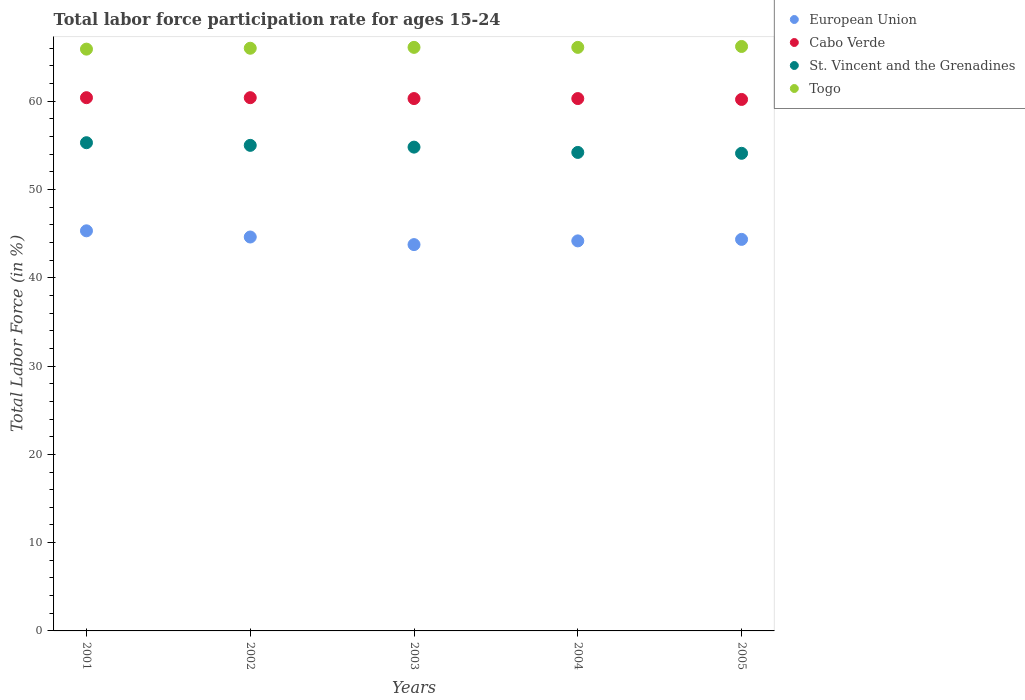Is the number of dotlines equal to the number of legend labels?
Offer a very short reply. Yes. What is the labor force participation rate in Cabo Verde in 2002?
Your answer should be very brief. 60.4. Across all years, what is the maximum labor force participation rate in St. Vincent and the Grenadines?
Make the answer very short. 55.3. Across all years, what is the minimum labor force participation rate in European Union?
Offer a very short reply. 43.76. In which year was the labor force participation rate in European Union maximum?
Provide a short and direct response. 2001. In which year was the labor force participation rate in St. Vincent and the Grenadines minimum?
Make the answer very short. 2005. What is the total labor force participation rate in European Union in the graph?
Offer a terse response. 222.23. What is the difference between the labor force participation rate in European Union in 2004 and that in 2005?
Provide a succinct answer. -0.17. What is the difference between the labor force participation rate in European Union in 2005 and the labor force participation rate in St. Vincent and the Grenadines in 2001?
Your answer should be compact. -10.95. What is the average labor force participation rate in Togo per year?
Provide a short and direct response. 66.06. In the year 2004, what is the difference between the labor force participation rate in Cabo Verde and labor force participation rate in St. Vincent and the Grenadines?
Make the answer very short. 6.1. In how many years, is the labor force participation rate in European Union greater than 54 %?
Keep it short and to the point. 0. What is the ratio of the labor force participation rate in European Union in 2004 to that in 2005?
Offer a terse response. 1. Is the labor force participation rate in Cabo Verde in 2002 less than that in 2005?
Offer a very short reply. No. What is the difference between the highest and the lowest labor force participation rate in Togo?
Your answer should be compact. 0.3. In how many years, is the labor force participation rate in St. Vincent and the Grenadines greater than the average labor force participation rate in St. Vincent and the Grenadines taken over all years?
Your answer should be compact. 3. Is it the case that in every year, the sum of the labor force participation rate in Togo and labor force participation rate in Cabo Verde  is greater than the sum of labor force participation rate in European Union and labor force participation rate in St. Vincent and the Grenadines?
Keep it short and to the point. Yes. Is it the case that in every year, the sum of the labor force participation rate in Togo and labor force participation rate in Cabo Verde  is greater than the labor force participation rate in European Union?
Keep it short and to the point. Yes. What is the difference between two consecutive major ticks on the Y-axis?
Ensure brevity in your answer.  10. Does the graph contain any zero values?
Ensure brevity in your answer.  No. Does the graph contain grids?
Give a very brief answer. No. Where does the legend appear in the graph?
Provide a short and direct response. Top right. How many legend labels are there?
Make the answer very short. 4. How are the legend labels stacked?
Your response must be concise. Vertical. What is the title of the graph?
Keep it short and to the point. Total labor force participation rate for ages 15-24. What is the Total Labor Force (in %) in European Union in 2001?
Make the answer very short. 45.32. What is the Total Labor Force (in %) in Cabo Verde in 2001?
Provide a short and direct response. 60.4. What is the Total Labor Force (in %) in St. Vincent and the Grenadines in 2001?
Your answer should be compact. 55.3. What is the Total Labor Force (in %) of Togo in 2001?
Make the answer very short. 65.9. What is the Total Labor Force (in %) of European Union in 2002?
Offer a very short reply. 44.62. What is the Total Labor Force (in %) of Cabo Verde in 2002?
Your answer should be compact. 60.4. What is the Total Labor Force (in %) of St. Vincent and the Grenadines in 2002?
Keep it short and to the point. 55. What is the Total Labor Force (in %) in European Union in 2003?
Offer a very short reply. 43.76. What is the Total Labor Force (in %) of Cabo Verde in 2003?
Your answer should be very brief. 60.3. What is the Total Labor Force (in %) of St. Vincent and the Grenadines in 2003?
Provide a short and direct response. 54.8. What is the Total Labor Force (in %) of Togo in 2003?
Your answer should be compact. 66.1. What is the Total Labor Force (in %) of European Union in 2004?
Your response must be concise. 44.18. What is the Total Labor Force (in %) of Cabo Verde in 2004?
Your answer should be compact. 60.3. What is the Total Labor Force (in %) in St. Vincent and the Grenadines in 2004?
Give a very brief answer. 54.2. What is the Total Labor Force (in %) in Togo in 2004?
Make the answer very short. 66.1. What is the Total Labor Force (in %) of European Union in 2005?
Your answer should be compact. 44.35. What is the Total Labor Force (in %) of Cabo Verde in 2005?
Provide a succinct answer. 60.2. What is the Total Labor Force (in %) of St. Vincent and the Grenadines in 2005?
Give a very brief answer. 54.1. What is the Total Labor Force (in %) in Togo in 2005?
Provide a short and direct response. 66.2. Across all years, what is the maximum Total Labor Force (in %) of European Union?
Your answer should be compact. 45.32. Across all years, what is the maximum Total Labor Force (in %) of Cabo Verde?
Offer a terse response. 60.4. Across all years, what is the maximum Total Labor Force (in %) in St. Vincent and the Grenadines?
Your answer should be compact. 55.3. Across all years, what is the maximum Total Labor Force (in %) in Togo?
Provide a short and direct response. 66.2. Across all years, what is the minimum Total Labor Force (in %) of European Union?
Offer a very short reply. 43.76. Across all years, what is the minimum Total Labor Force (in %) of Cabo Verde?
Give a very brief answer. 60.2. Across all years, what is the minimum Total Labor Force (in %) of St. Vincent and the Grenadines?
Give a very brief answer. 54.1. Across all years, what is the minimum Total Labor Force (in %) of Togo?
Give a very brief answer. 65.9. What is the total Total Labor Force (in %) in European Union in the graph?
Give a very brief answer. 222.23. What is the total Total Labor Force (in %) of Cabo Verde in the graph?
Your answer should be very brief. 301.6. What is the total Total Labor Force (in %) in St. Vincent and the Grenadines in the graph?
Your answer should be compact. 273.4. What is the total Total Labor Force (in %) of Togo in the graph?
Your answer should be compact. 330.3. What is the difference between the Total Labor Force (in %) in European Union in 2001 and that in 2002?
Your answer should be very brief. 0.7. What is the difference between the Total Labor Force (in %) in St. Vincent and the Grenadines in 2001 and that in 2002?
Ensure brevity in your answer.  0.3. What is the difference between the Total Labor Force (in %) of European Union in 2001 and that in 2003?
Your answer should be very brief. 1.56. What is the difference between the Total Labor Force (in %) in European Union in 2001 and that in 2004?
Offer a terse response. 1.14. What is the difference between the Total Labor Force (in %) of Togo in 2001 and that in 2004?
Your answer should be compact. -0.2. What is the difference between the Total Labor Force (in %) in European Union in 2001 and that in 2005?
Provide a short and direct response. 0.97. What is the difference between the Total Labor Force (in %) in Togo in 2001 and that in 2005?
Your answer should be very brief. -0.3. What is the difference between the Total Labor Force (in %) of European Union in 2002 and that in 2003?
Offer a very short reply. 0.86. What is the difference between the Total Labor Force (in %) of St. Vincent and the Grenadines in 2002 and that in 2003?
Make the answer very short. 0.2. What is the difference between the Total Labor Force (in %) of European Union in 2002 and that in 2004?
Your answer should be very brief. 0.44. What is the difference between the Total Labor Force (in %) in Cabo Verde in 2002 and that in 2004?
Ensure brevity in your answer.  0.1. What is the difference between the Total Labor Force (in %) of European Union in 2002 and that in 2005?
Your answer should be very brief. 0.27. What is the difference between the Total Labor Force (in %) in St. Vincent and the Grenadines in 2002 and that in 2005?
Keep it short and to the point. 0.9. What is the difference between the Total Labor Force (in %) of Togo in 2002 and that in 2005?
Provide a short and direct response. -0.2. What is the difference between the Total Labor Force (in %) of European Union in 2003 and that in 2004?
Ensure brevity in your answer.  -0.42. What is the difference between the Total Labor Force (in %) in Cabo Verde in 2003 and that in 2004?
Ensure brevity in your answer.  0. What is the difference between the Total Labor Force (in %) in St. Vincent and the Grenadines in 2003 and that in 2004?
Keep it short and to the point. 0.6. What is the difference between the Total Labor Force (in %) of Togo in 2003 and that in 2004?
Keep it short and to the point. 0. What is the difference between the Total Labor Force (in %) in European Union in 2003 and that in 2005?
Your response must be concise. -0.59. What is the difference between the Total Labor Force (in %) in St. Vincent and the Grenadines in 2003 and that in 2005?
Offer a very short reply. 0.7. What is the difference between the Total Labor Force (in %) in European Union in 2004 and that in 2005?
Offer a very short reply. -0.17. What is the difference between the Total Labor Force (in %) of Cabo Verde in 2004 and that in 2005?
Provide a succinct answer. 0.1. What is the difference between the Total Labor Force (in %) of Togo in 2004 and that in 2005?
Provide a succinct answer. -0.1. What is the difference between the Total Labor Force (in %) in European Union in 2001 and the Total Labor Force (in %) in Cabo Verde in 2002?
Offer a very short reply. -15.08. What is the difference between the Total Labor Force (in %) in European Union in 2001 and the Total Labor Force (in %) in St. Vincent and the Grenadines in 2002?
Ensure brevity in your answer.  -9.68. What is the difference between the Total Labor Force (in %) in European Union in 2001 and the Total Labor Force (in %) in Togo in 2002?
Provide a succinct answer. -20.68. What is the difference between the Total Labor Force (in %) of European Union in 2001 and the Total Labor Force (in %) of Cabo Verde in 2003?
Offer a terse response. -14.98. What is the difference between the Total Labor Force (in %) of European Union in 2001 and the Total Labor Force (in %) of St. Vincent and the Grenadines in 2003?
Provide a succinct answer. -9.48. What is the difference between the Total Labor Force (in %) in European Union in 2001 and the Total Labor Force (in %) in Togo in 2003?
Offer a very short reply. -20.78. What is the difference between the Total Labor Force (in %) of St. Vincent and the Grenadines in 2001 and the Total Labor Force (in %) of Togo in 2003?
Your answer should be compact. -10.8. What is the difference between the Total Labor Force (in %) of European Union in 2001 and the Total Labor Force (in %) of Cabo Verde in 2004?
Provide a succinct answer. -14.98. What is the difference between the Total Labor Force (in %) of European Union in 2001 and the Total Labor Force (in %) of St. Vincent and the Grenadines in 2004?
Offer a terse response. -8.88. What is the difference between the Total Labor Force (in %) of European Union in 2001 and the Total Labor Force (in %) of Togo in 2004?
Provide a short and direct response. -20.78. What is the difference between the Total Labor Force (in %) of Cabo Verde in 2001 and the Total Labor Force (in %) of Togo in 2004?
Keep it short and to the point. -5.7. What is the difference between the Total Labor Force (in %) of European Union in 2001 and the Total Labor Force (in %) of Cabo Verde in 2005?
Your answer should be very brief. -14.88. What is the difference between the Total Labor Force (in %) in European Union in 2001 and the Total Labor Force (in %) in St. Vincent and the Grenadines in 2005?
Your answer should be compact. -8.78. What is the difference between the Total Labor Force (in %) in European Union in 2001 and the Total Labor Force (in %) in Togo in 2005?
Offer a terse response. -20.88. What is the difference between the Total Labor Force (in %) in European Union in 2002 and the Total Labor Force (in %) in Cabo Verde in 2003?
Your response must be concise. -15.68. What is the difference between the Total Labor Force (in %) in European Union in 2002 and the Total Labor Force (in %) in St. Vincent and the Grenadines in 2003?
Your response must be concise. -10.18. What is the difference between the Total Labor Force (in %) in European Union in 2002 and the Total Labor Force (in %) in Togo in 2003?
Ensure brevity in your answer.  -21.48. What is the difference between the Total Labor Force (in %) of Cabo Verde in 2002 and the Total Labor Force (in %) of St. Vincent and the Grenadines in 2003?
Your answer should be very brief. 5.6. What is the difference between the Total Labor Force (in %) of St. Vincent and the Grenadines in 2002 and the Total Labor Force (in %) of Togo in 2003?
Make the answer very short. -11.1. What is the difference between the Total Labor Force (in %) in European Union in 2002 and the Total Labor Force (in %) in Cabo Verde in 2004?
Your answer should be very brief. -15.68. What is the difference between the Total Labor Force (in %) of European Union in 2002 and the Total Labor Force (in %) of St. Vincent and the Grenadines in 2004?
Offer a terse response. -9.58. What is the difference between the Total Labor Force (in %) of European Union in 2002 and the Total Labor Force (in %) of Togo in 2004?
Provide a succinct answer. -21.48. What is the difference between the Total Labor Force (in %) in Cabo Verde in 2002 and the Total Labor Force (in %) in St. Vincent and the Grenadines in 2004?
Keep it short and to the point. 6.2. What is the difference between the Total Labor Force (in %) of Cabo Verde in 2002 and the Total Labor Force (in %) of Togo in 2004?
Give a very brief answer. -5.7. What is the difference between the Total Labor Force (in %) of European Union in 2002 and the Total Labor Force (in %) of Cabo Verde in 2005?
Offer a very short reply. -15.58. What is the difference between the Total Labor Force (in %) in European Union in 2002 and the Total Labor Force (in %) in St. Vincent and the Grenadines in 2005?
Your response must be concise. -9.48. What is the difference between the Total Labor Force (in %) in European Union in 2002 and the Total Labor Force (in %) in Togo in 2005?
Keep it short and to the point. -21.58. What is the difference between the Total Labor Force (in %) in Cabo Verde in 2002 and the Total Labor Force (in %) in St. Vincent and the Grenadines in 2005?
Provide a succinct answer. 6.3. What is the difference between the Total Labor Force (in %) in Cabo Verde in 2002 and the Total Labor Force (in %) in Togo in 2005?
Provide a short and direct response. -5.8. What is the difference between the Total Labor Force (in %) in St. Vincent and the Grenadines in 2002 and the Total Labor Force (in %) in Togo in 2005?
Your response must be concise. -11.2. What is the difference between the Total Labor Force (in %) of European Union in 2003 and the Total Labor Force (in %) of Cabo Verde in 2004?
Provide a succinct answer. -16.54. What is the difference between the Total Labor Force (in %) of European Union in 2003 and the Total Labor Force (in %) of St. Vincent and the Grenadines in 2004?
Provide a short and direct response. -10.44. What is the difference between the Total Labor Force (in %) of European Union in 2003 and the Total Labor Force (in %) of Togo in 2004?
Make the answer very short. -22.34. What is the difference between the Total Labor Force (in %) in Cabo Verde in 2003 and the Total Labor Force (in %) in St. Vincent and the Grenadines in 2004?
Provide a succinct answer. 6.1. What is the difference between the Total Labor Force (in %) of St. Vincent and the Grenadines in 2003 and the Total Labor Force (in %) of Togo in 2004?
Offer a very short reply. -11.3. What is the difference between the Total Labor Force (in %) of European Union in 2003 and the Total Labor Force (in %) of Cabo Verde in 2005?
Give a very brief answer. -16.44. What is the difference between the Total Labor Force (in %) in European Union in 2003 and the Total Labor Force (in %) in St. Vincent and the Grenadines in 2005?
Make the answer very short. -10.34. What is the difference between the Total Labor Force (in %) of European Union in 2003 and the Total Labor Force (in %) of Togo in 2005?
Your answer should be compact. -22.44. What is the difference between the Total Labor Force (in %) of Cabo Verde in 2003 and the Total Labor Force (in %) of St. Vincent and the Grenadines in 2005?
Ensure brevity in your answer.  6.2. What is the difference between the Total Labor Force (in %) in Cabo Verde in 2003 and the Total Labor Force (in %) in Togo in 2005?
Make the answer very short. -5.9. What is the difference between the Total Labor Force (in %) of St. Vincent and the Grenadines in 2003 and the Total Labor Force (in %) of Togo in 2005?
Offer a very short reply. -11.4. What is the difference between the Total Labor Force (in %) in European Union in 2004 and the Total Labor Force (in %) in Cabo Verde in 2005?
Your answer should be very brief. -16.02. What is the difference between the Total Labor Force (in %) of European Union in 2004 and the Total Labor Force (in %) of St. Vincent and the Grenadines in 2005?
Offer a very short reply. -9.92. What is the difference between the Total Labor Force (in %) of European Union in 2004 and the Total Labor Force (in %) of Togo in 2005?
Your response must be concise. -22.02. What is the difference between the Total Labor Force (in %) of St. Vincent and the Grenadines in 2004 and the Total Labor Force (in %) of Togo in 2005?
Offer a terse response. -12. What is the average Total Labor Force (in %) of European Union per year?
Give a very brief answer. 44.45. What is the average Total Labor Force (in %) in Cabo Verde per year?
Your answer should be very brief. 60.32. What is the average Total Labor Force (in %) of St. Vincent and the Grenadines per year?
Your answer should be compact. 54.68. What is the average Total Labor Force (in %) in Togo per year?
Make the answer very short. 66.06. In the year 2001, what is the difference between the Total Labor Force (in %) in European Union and Total Labor Force (in %) in Cabo Verde?
Make the answer very short. -15.08. In the year 2001, what is the difference between the Total Labor Force (in %) in European Union and Total Labor Force (in %) in St. Vincent and the Grenadines?
Provide a short and direct response. -9.98. In the year 2001, what is the difference between the Total Labor Force (in %) in European Union and Total Labor Force (in %) in Togo?
Your answer should be compact. -20.58. In the year 2001, what is the difference between the Total Labor Force (in %) of Cabo Verde and Total Labor Force (in %) of St. Vincent and the Grenadines?
Your answer should be very brief. 5.1. In the year 2001, what is the difference between the Total Labor Force (in %) in Cabo Verde and Total Labor Force (in %) in Togo?
Offer a very short reply. -5.5. In the year 2001, what is the difference between the Total Labor Force (in %) of St. Vincent and the Grenadines and Total Labor Force (in %) of Togo?
Give a very brief answer. -10.6. In the year 2002, what is the difference between the Total Labor Force (in %) in European Union and Total Labor Force (in %) in Cabo Verde?
Provide a short and direct response. -15.78. In the year 2002, what is the difference between the Total Labor Force (in %) of European Union and Total Labor Force (in %) of St. Vincent and the Grenadines?
Your response must be concise. -10.38. In the year 2002, what is the difference between the Total Labor Force (in %) in European Union and Total Labor Force (in %) in Togo?
Give a very brief answer. -21.38. In the year 2002, what is the difference between the Total Labor Force (in %) in Cabo Verde and Total Labor Force (in %) in St. Vincent and the Grenadines?
Provide a short and direct response. 5.4. In the year 2002, what is the difference between the Total Labor Force (in %) of Cabo Verde and Total Labor Force (in %) of Togo?
Your response must be concise. -5.6. In the year 2002, what is the difference between the Total Labor Force (in %) in St. Vincent and the Grenadines and Total Labor Force (in %) in Togo?
Your answer should be compact. -11. In the year 2003, what is the difference between the Total Labor Force (in %) of European Union and Total Labor Force (in %) of Cabo Verde?
Your answer should be very brief. -16.54. In the year 2003, what is the difference between the Total Labor Force (in %) in European Union and Total Labor Force (in %) in St. Vincent and the Grenadines?
Offer a very short reply. -11.04. In the year 2003, what is the difference between the Total Labor Force (in %) in European Union and Total Labor Force (in %) in Togo?
Provide a short and direct response. -22.34. In the year 2003, what is the difference between the Total Labor Force (in %) of Cabo Verde and Total Labor Force (in %) of Togo?
Offer a very short reply. -5.8. In the year 2004, what is the difference between the Total Labor Force (in %) of European Union and Total Labor Force (in %) of Cabo Verde?
Make the answer very short. -16.12. In the year 2004, what is the difference between the Total Labor Force (in %) of European Union and Total Labor Force (in %) of St. Vincent and the Grenadines?
Give a very brief answer. -10.02. In the year 2004, what is the difference between the Total Labor Force (in %) in European Union and Total Labor Force (in %) in Togo?
Your response must be concise. -21.92. In the year 2005, what is the difference between the Total Labor Force (in %) of European Union and Total Labor Force (in %) of Cabo Verde?
Keep it short and to the point. -15.85. In the year 2005, what is the difference between the Total Labor Force (in %) in European Union and Total Labor Force (in %) in St. Vincent and the Grenadines?
Offer a terse response. -9.75. In the year 2005, what is the difference between the Total Labor Force (in %) of European Union and Total Labor Force (in %) of Togo?
Your answer should be compact. -21.85. In the year 2005, what is the difference between the Total Labor Force (in %) in Cabo Verde and Total Labor Force (in %) in Togo?
Your answer should be very brief. -6. What is the ratio of the Total Labor Force (in %) in European Union in 2001 to that in 2002?
Your answer should be compact. 1.02. What is the ratio of the Total Labor Force (in %) of Cabo Verde in 2001 to that in 2002?
Keep it short and to the point. 1. What is the ratio of the Total Labor Force (in %) of St. Vincent and the Grenadines in 2001 to that in 2002?
Keep it short and to the point. 1.01. What is the ratio of the Total Labor Force (in %) in European Union in 2001 to that in 2003?
Provide a short and direct response. 1.04. What is the ratio of the Total Labor Force (in %) of Cabo Verde in 2001 to that in 2003?
Provide a short and direct response. 1. What is the ratio of the Total Labor Force (in %) of St. Vincent and the Grenadines in 2001 to that in 2003?
Your answer should be compact. 1.01. What is the ratio of the Total Labor Force (in %) in European Union in 2001 to that in 2004?
Keep it short and to the point. 1.03. What is the ratio of the Total Labor Force (in %) in St. Vincent and the Grenadines in 2001 to that in 2004?
Give a very brief answer. 1.02. What is the ratio of the Total Labor Force (in %) of European Union in 2001 to that in 2005?
Your response must be concise. 1.02. What is the ratio of the Total Labor Force (in %) in Cabo Verde in 2001 to that in 2005?
Provide a short and direct response. 1. What is the ratio of the Total Labor Force (in %) in St. Vincent and the Grenadines in 2001 to that in 2005?
Give a very brief answer. 1.02. What is the ratio of the Total Labor Force (in %) in European Union in 2002 to that in 2003?
Provide a succinct answer. 1.02. What is the ratio of the Total Labor Force (in %) of Cabo Verde in 2002 to that in 2003?
Provide a short and direct response. 1. What is the ratio of the Total Labor Force (in %) of Togo in 2002 to that in 2003?
Keep it short and to the point. 1. What is the ratio of the Total Labor Force (in %) of European Union in 2002 to that in 2004?
Ensure brevity in your answer.  1.01. What is the ratio of the Total Labor Force (in %) in St. Vincent and the Grenadines in 2002 to that in 2004?
Your response must be concise. 1.01. What is the ratio of the Total Labor Force (in %) in St. Vincent and the Grenadines in 2002 to that in 2005?
Provide a short and direct response. 1.02. What is the ratio of the Total Labor Force (in %) of Togo in 2002 to that in 2005?
Give a very brief answer. 1. What is the ratio of the Total Labor Force (in %) in St. Vincent and the Grenadines in 2003 to that in 2004?
Keep it short and to the point. 1.01. What is the ratio of the Total Labor Force (in %) in European Union in 2003 to that in 2005?
Your answer should be compact. 0.99. What is the ratio of the Total Labor Force (in %) in St. Vincent and the Grenadines in 2003 to that in 2005?
Provide a succinct answer. 1.01. What is the ratio of the Total Labor Force (in %) of Togo in 2003 to that in 2005?
Your answer should be compact. 1. What is the ratio of the Total Labor Force (in %) in European Union in 2004 to that in 2005?
Your answer should be very brief. 1. What is the ratio of the Total Labor Force (in %) in Cabo Verde in 2004 to that in 2005?
Provide a short and direct response. 1. What is the difference between the highest and the second highest Total Labor Force (in %) in European Union?
Provide a succinct answer. 0.7. What is the difference between the highest and the second highest Total Labor Force (in %) in Cabo Verde?
Ensure brevity in your answer.  0. What is the difference between the highest and the second highest Total Labor Force (in %) of St. Vincent and the Grenadines?
Give a very brief answer. 0.3. What is the difference between the highest and the second highest Total Labor Force (in %) in Togo?
Keep it short and to the point. 0.1. What is the difference between the highest and the lowest Total Labor Force (in %) of European Union?
Keep it short and to the point. 1.56. 